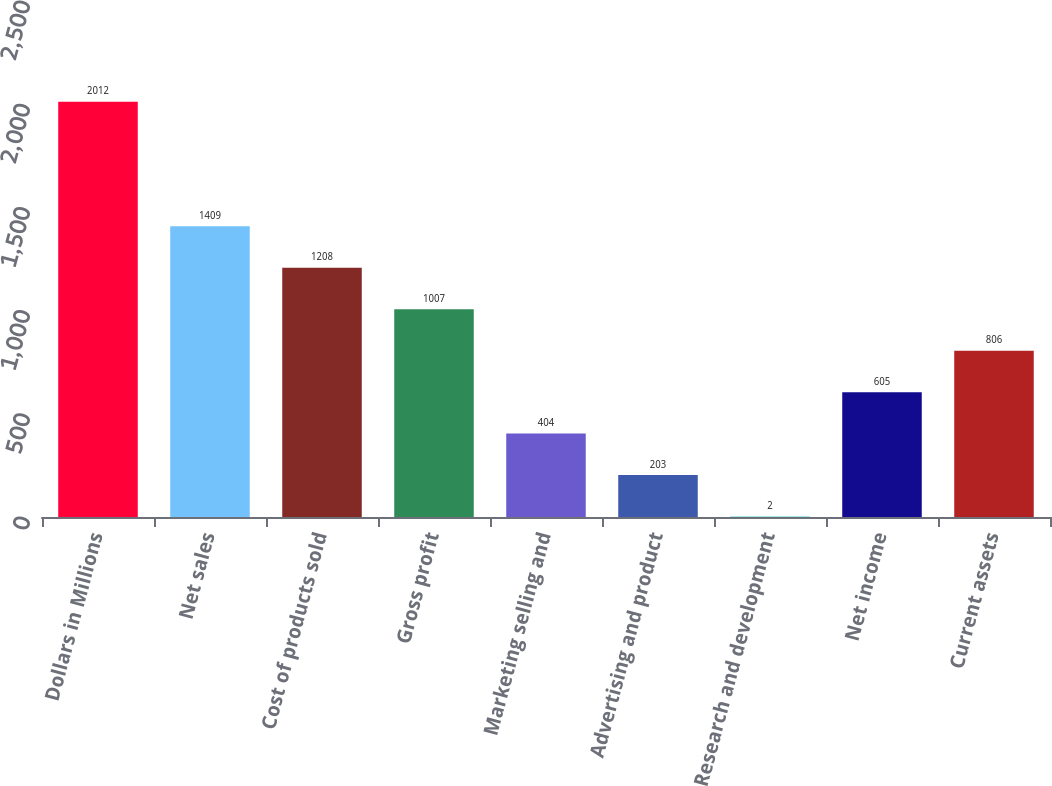Convert chart to OTSL. <chart><loc_0><loc_0><loc_500><loc_500><bar_chart><fcel>Dollars in Millions<fcel>Net sales<fcel>Cost of products sold<fcel>Gross profit<fcel>Marketing selling and<fcel>Advertising and product<fcel>Research and development<fcel>Net income<fcel>Current assets<nl><fcel>2012<fcel>1409<fcel>1208<fcel>1007<fcel>404<fcel>203<fcel>2<fcel>605<fcel>806<nl></chart> 